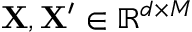<formula> <loc_0><loc_0><loc_500><loc_500>X , X ^ { \prime } \in \mathbb { R } ^ { d \times M }</formula> 